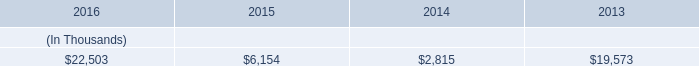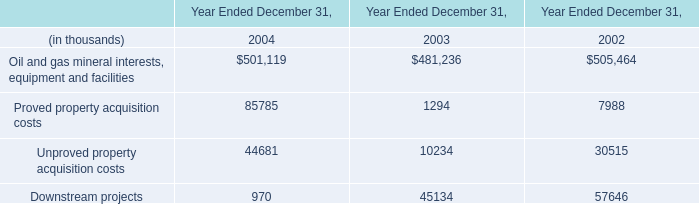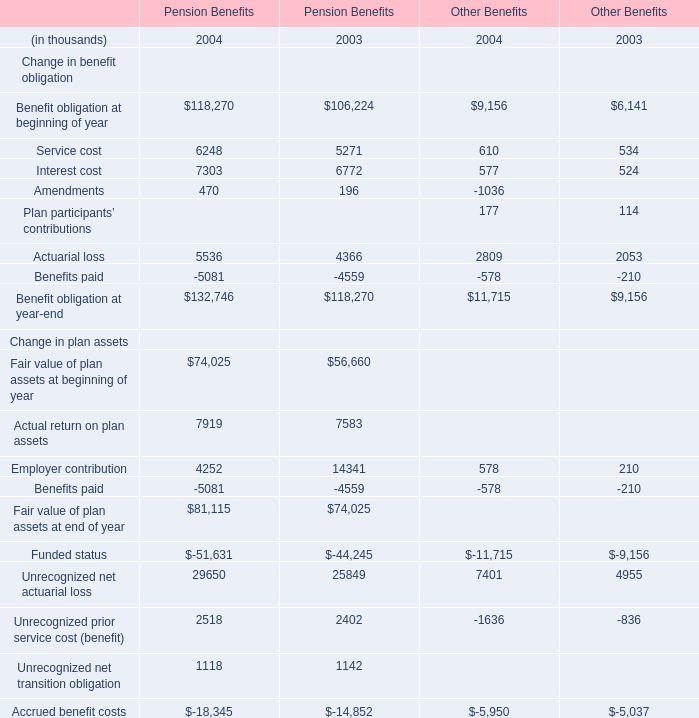If Fair value of plan assets at beginning of year for Pension Benefits develops with the same growth rate in 2004, what will it reach in 2005? (in thousand) 
Computations: (74025 * (1 + ((74025 - 56660) / 56660)))
Answer: 96711.97714. 